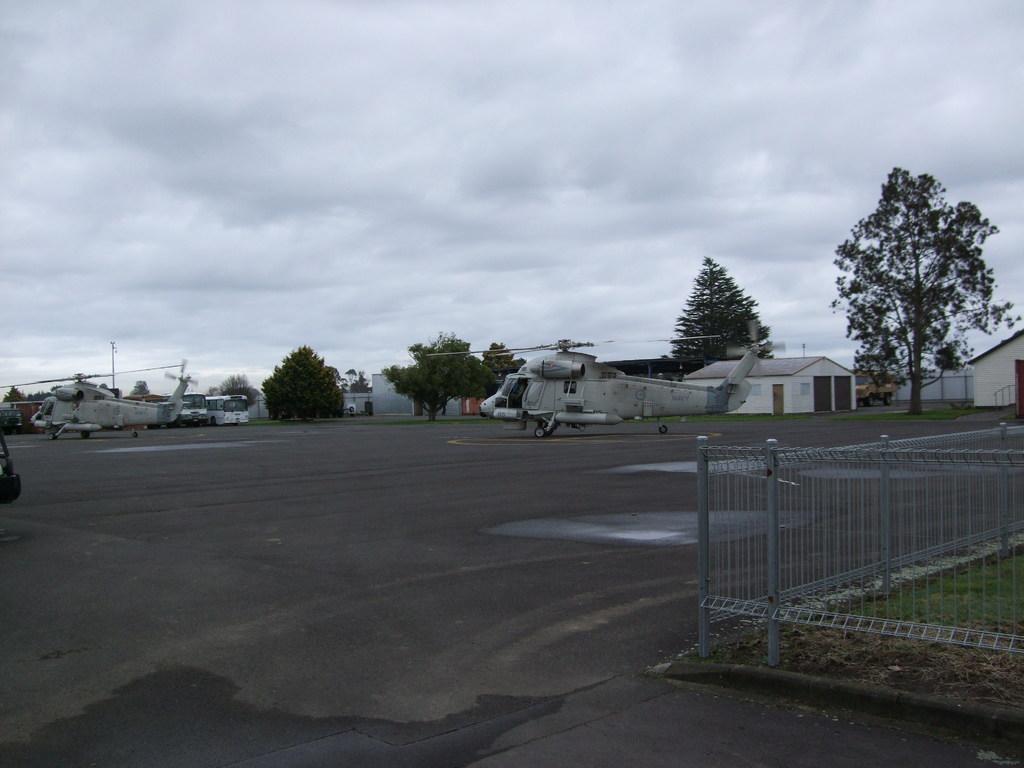Describe this image in one or two sentences. In this image two helicopters and few vehicles are on the road. Behind there are few trees and houses. Right side there is a fence , behind there is grassland. Top of image there is sky with some clouds. 